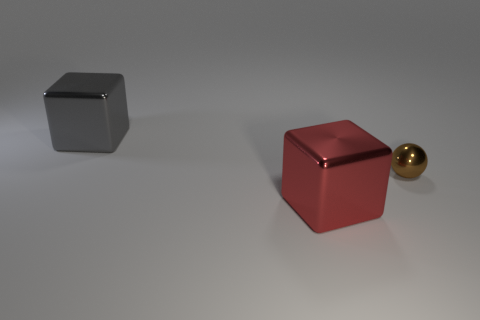Add 2 big gray metal blocks. How many objects exist? 5 Subtract all blocks. How many objects are left? 1 Subtract 0 cyan cubes. How many objects are left? 3 Subtract all red things. Subtract all big red shiny objects. How many objects are left? 1 Add 3 large red metallic cubes. How many large red metallic cubes are left? 4 Add 1 tiny brown metal balls. How many tiny brown metal balls exist? 2 